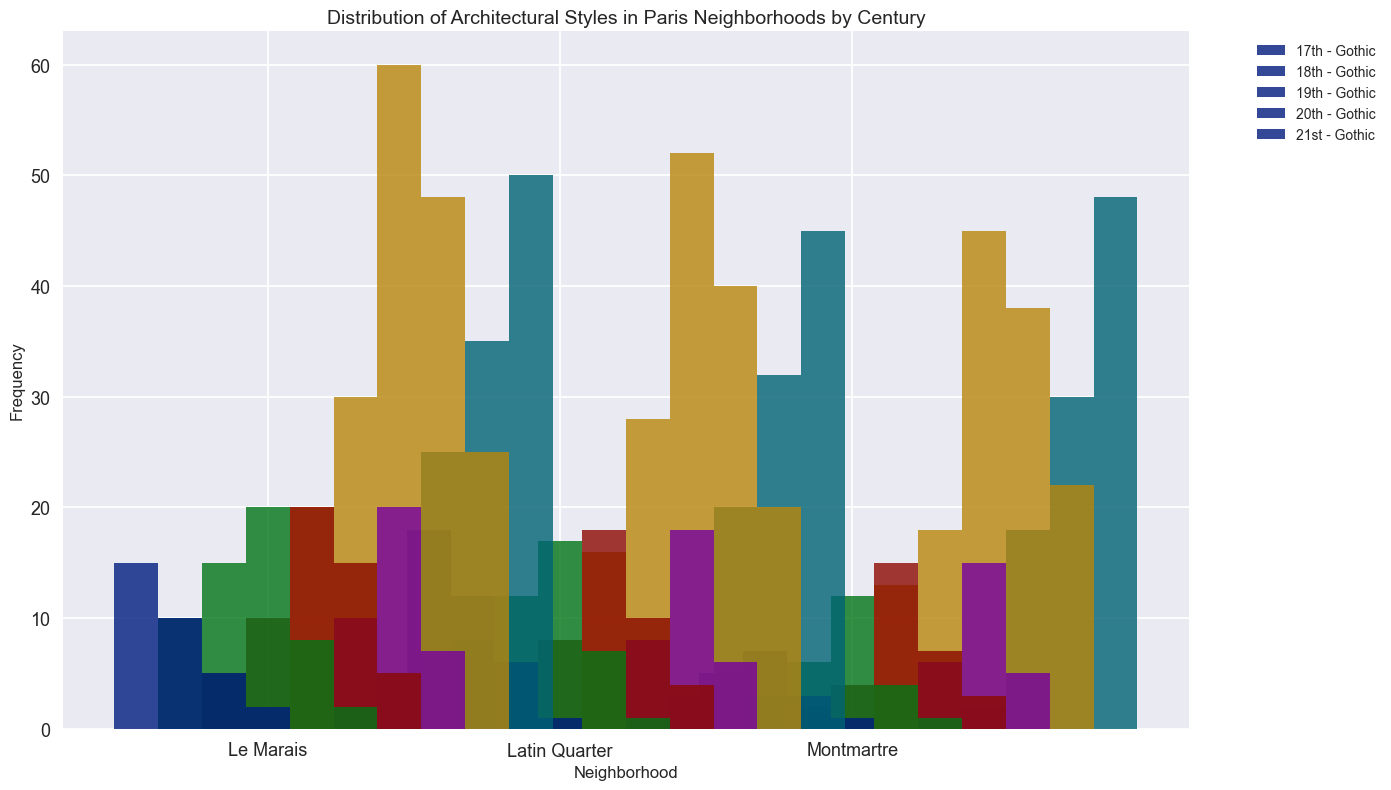Which neighborhood had the highest frequency of Modern architecture in the 21st century? Look for the tallest bar in the 21st-century group and compare the heights across neighborhoods for the Modern style.
Answer: Le Marais Comparing the 19th century, which neighborhood had more Haussmannian buildings, Le Marais or Latin Quarter? Compare the heights of the Haussmannian bars for Le Marais and Latin Quarter in the 19th-century group.
Answer: Le Marais How many Baroque buildings were there in total across all neighborhoods in the 18th century? Sum the number of Baroque buildings for Le Marais, Latin Quarter, and Montmartre in the 18th century. The values are 15, 12, and 6, respectively. So, 15 + 12 + 6 = 33.
Answer: 33 Which architectural style saw the largest increase from the 17th to the 19th century in Montmartre? Compare the frequency counts of each style in Montmartre between the 17th and 19th centuries. The largest increase is observed in the Haussmannian style, which increased from 13 to 45.
Answer: Haussmannian What is the combined frequency of Gothic and Art Nouveau styles in the Latin Quarter during the 20th century? Add the frequency of Gothic and Art Nouveau buildings in the 20th century for the Latin Quarter. Gothic is 1, and Art Nouveau is 18. So, 1 + 18 = 19.
Answer: 19 Which century had the lowest frequency of Neoclassical buildings in Montmartre? Compare the heights of the Neoclassical bars for Montmartre across all centuries and find the shortest one.
Answer: 17th century In the 18th century, which neighborhood had the smallest number of Gothic buildings? Compare the heights of the Gothic bars for each neighborhood in the 18th century, and find the shortest one.
Answer: Montmartre How did the frequency of Baroque buildings change in Le Marais from the 17th to the 21st century? Compare the heights of the Baroque bars in Le Marais from the 17th to the 21st century. The frequencies are 10 (17th), 15 (18th), 20 (19th), 8 (20th), and 2 (21st). The change shows an initial increase and then a gradual decrease.
Answer: Increased from 17th to 19th century and then decreased to 21st century Which architectural style in Montmartre has a consistently low frequency across all centuries? Check the heights of all the bars in Montmartre for each style in each century, and note the one that remains low.
Answer: Gothic 